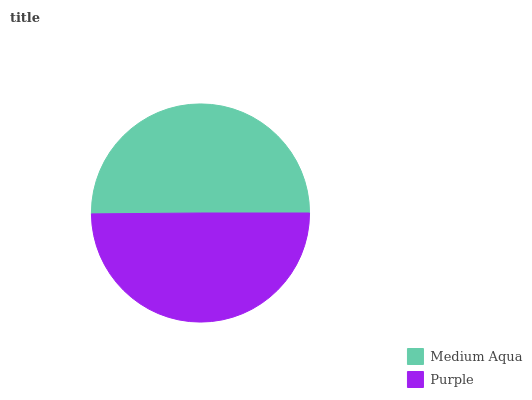Is Purple the minimum?
Answer yes or no. Yes. Is Medium Aqua the maximum?
Answer yes or no. Yes. Is Purple the maximum?
Answer yes or no. No. Is Medium Aqua greater than Purple?
Answer yes or no. Yes. Is Purple less than Medium Aqua?
Answer yes or no. Yes. Is Purple greater than Medium Aqua?
Answer yes or no. No. Is Medium Aqua less than Purple?
Answer yes or no. No. Is Medium Aqua the high median?
Answer yes or no. Yes. Is Purple the low median?
Answer yes or no. Yes. Is Purple the high median?
Answer yes or no. No. Is Medium Aqua the low median?
Answer yes or no. No. 